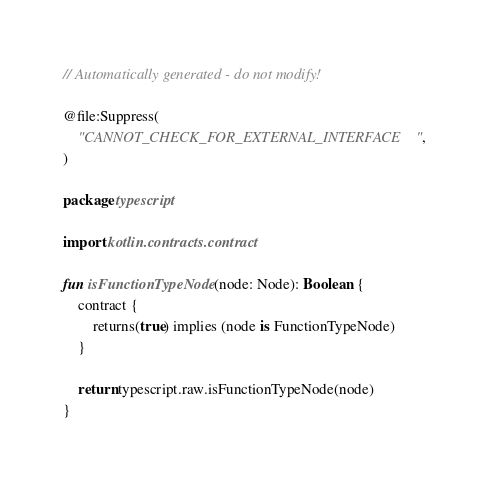<code> <loc_0><loc_0><loc_500><loc_500><_Kotlin_>// Automatically generated - do not modify!

@file:Suppress(
    "CANNOT_CHECK_FOR_EXTERNAL_INTERFACE",
)

package typescript

import kotlin.contracts.contract

fun isFunctionTypeNode(node: Node): Boolean {
    contract {
        returns(true) implies (node is FunctionTypeNode)
    }

    return typescript.raw.isFunctionTypeNode(node)
}
</code> 